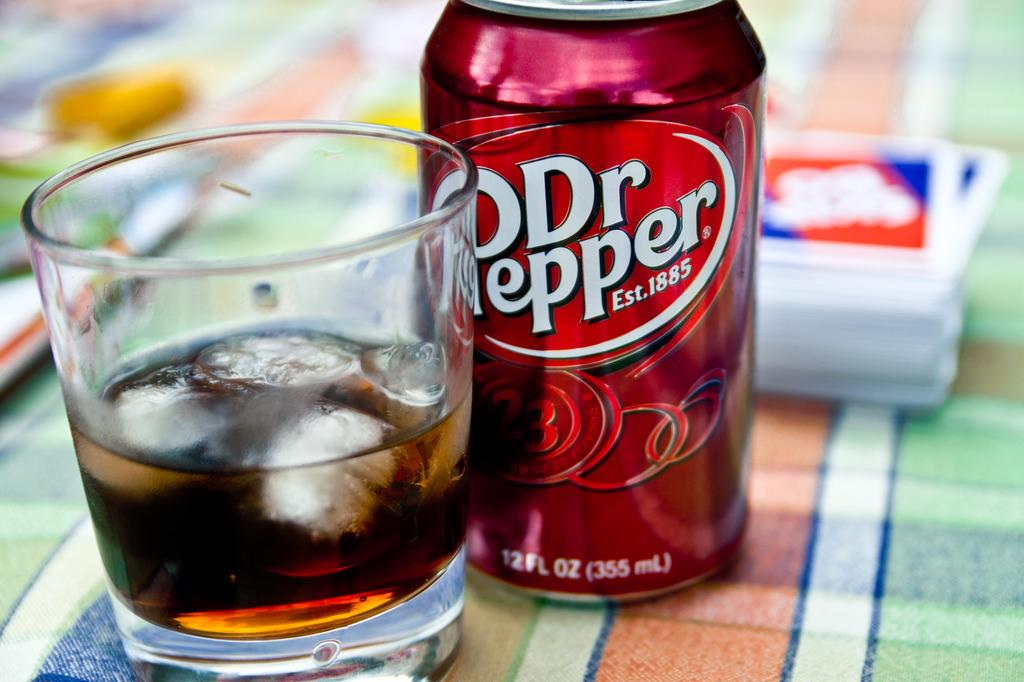<image>
Provide a brief description of the given image. a can and glass of Dr Pepper Est 1885 